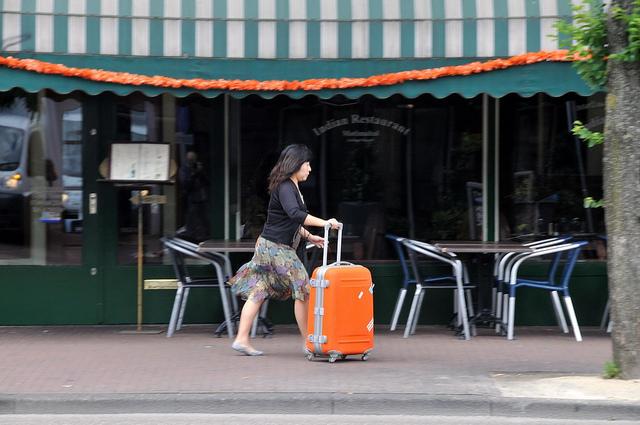How many chairs in the photo?
Keep it brief. 6. Does she look lost?
Answer briefly. No. What color is here luggage?
Answer briefly. Orange. 